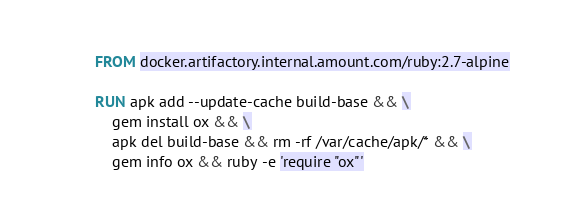Convert code to text. <code><loc_0><loc_0><loc_500><loc_500><_Dockerfile_>FROM docker.artifactory.internal.amount.com/ruby:2.7-alpine

RUN apk add --update-cache build-base && \
    gem install ox && \
    apk del build-base && rm -rf /var/cache/apk/* && \
    gem info ox && ruby -e 'require "ox"'
</code> 